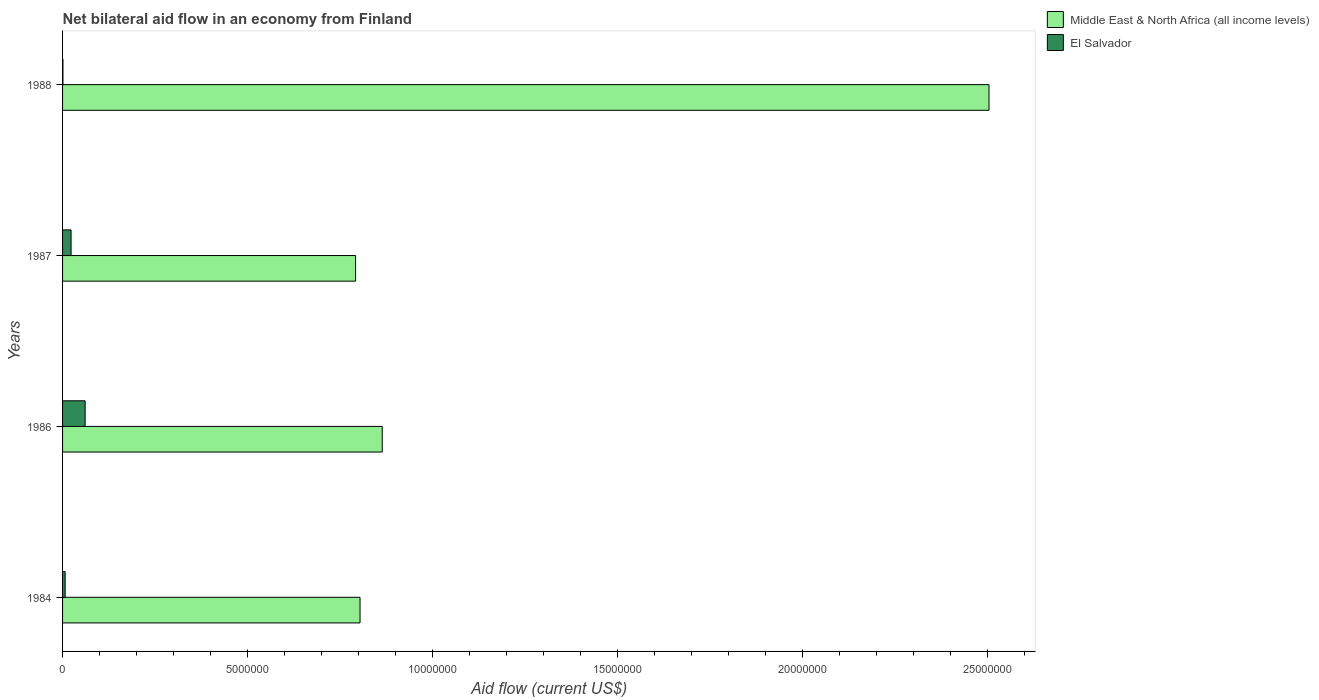How many groups of bars are there?
Your response must be concise. 4. Are the number of bars per tick equal to the number of legend labels?
Make the answer very short. Yes. How many bars are there on the 3rd tick from the top?
Provide a succinct answer. 2. How many bars are there on the 2nd tick from the bottom?
Your answer should be compact. 2. What is the label of the 2nd group of bars from the top?
Give a very brief answer. 1987. In how many cases, is the number of bars for a given year not equal to the number of legend labels?
Make the answer very short. 0. What is the net bilateral aid flow in Middle East & North Africa (all income levels) in 1987?
Make the answer very short. 7.92e+06. Across all years, what is the minimum net bilateral aid flow in Middle East & North Africa (all income levels)?
Your answer should be compact. 7.92e+06. In which year was the net bilateral aid flow in Middle East & North Africa (all income levels) minimum?
Provide a short and direct response. 1987. What is the total net bilateral aid flow in Middle East & North Africa (all income levels) in the graph?
Your answer should be compact. 4.96e+07. What is the difference between the net bilateral aid flow in Middle East & North Africa (all income levels) in 1984 and that in 1987?
Ensure brevity in your answer.  1.20e+05. What is the difference between the net bilateral aid flow in El Salvador in 1988 and the net bilateral aid flow in Middle East & North Africa (all income levels) in 1986?
Make the answer very short. -8.63e+06. What is the average net bilateral aid flow in El Salvador per year?
Keep it short and to the point. 2.30e+05. In the year 1988, what is the difference between the net bilateral aid flow in El Salvador and net bilateral aid flow in Middle East & North Africa (all income levels)?
Your answer should be very brief. -2.50e+07. In how many years, is the net bilateral aid flow in El Salvador greater than 1000000 US$?
Your answer should be compact. 0. What is the ratio of the net bilateral aid flow in Middle East & North Africa (all income levels) in 1984 to that in 1986?
Offer a very short reply. 0.93. Is the net bilateral aid flow in Middle East & North Africa (all income levels) in 1984 less than that in 1988?
Your answer should be compact. Yes. Is the difference between the net bilateral aid flow in El Salvador in 1984 and 1988 greater than the difference between the net bilateral aid flow in Middle East & North Africa (all income levels) in 1984 and 1988?
Your answer should be compact. Yes. What is the difference between the highest and the second highest net bilateral aid flow in Middle East & North Africa (all income levels)?
Make the answer very short. 1.64e+07. What is the difference between the highest and the lowest net bilateral aid flow in Middle East & North Africa (all income levels)?
Make the answer very short. 1.71e+07. Is the sum of the net bilateral aid flow in Middle East & North Africa (all income levels) in 1984 and 1987 greater than the maximum net bilateral aid flow in El Salvador across all years?
Keep it short and to the point. Yes. What does the 2nd bar from the top in 1986 represents?
Your response must be concise. Middle East & North Africa (all income levels). What does the 2nd bar from the bottom in 1987 represents?
Your answer should be very brief. El Salvador. How many bars are there?
Offer a terse response. 8. Are all the bars in the graph horizontal?
Keep it short and to the point. Yes. How many years are there in the graph?
Your answer should be very brief. 4. Are the values on the major ticks of X-axis written in scientific E-notation?
Your answer should be compact. No. Does the graph contain any zero values?
Your response must be concise. No. How are the legend labels stacked?
Offer a terse response. Vertical. What is the title of the graph?
Your answer should be very brief. Net bilateral aid flow in an economy from Finland. Does "Djibouti" appear as one of the legend labels in the graph?
Ensure brevity in your answer.  No. What is the label or title of the X-axis?
Ensure brevity in your answer.  Aid flow (current US$). What is the label or title of the Y-axis?
Offer a terse response. Years. What is the Aid flow (current US$) in Middle East & North Africa (all income levels) in 1984?
Offer a very short reply. 8.04e+06. What is the Aid flow (current US$) in Middle East & North Africa (all income levels) in 1986?
Provide a succinct answer. 8.64e+06. What is the Aid flow (current US$) in Middle East & North Africa (all income levels) in 1987?
Offer a terse response. 7.92e+06. What is the Aid flow (current US$) of Middle East & North Africa (all income levels) in 1988?
Provide a short and direct response. 2.50e+07. What is the Aid flow (current US$) in El Salvador in 1988?
Give a very brief answer. 10000. Across all years, what is the maximum Aid flow (current US$) of Middle East & North Africa (all income levels)?
Ensure brevity in your answer.  2.50e+07. Across all years, what is the minimum Aid flow (current US$) in Middle East & North Africa (all income levels)?
Keep it short and to the point. 7.92e+06. What is the total Aid flow (current US$) in Middle East & North Africa (all income levels) in the graph?
Ensure brevity in your answer.  4.96e+07. What is the total Aid flow (current US$) in El Salvador in the graph?
Provide a short and direct response. 9.20e+05. What is the difference between the Aid flow (current US$) in Middle East & North Africa (all income levels) in 1984 and that in 1986?
Offer a very short reply. -6.00e+05. What is the difference between the Aid flow (current US$) in El Salvador in 1984 and that in 1986?
Your answer should be compact. -5.40e+05. What is the difference between the Aid flow (current US$) in Middle East & North Africa (all income levels) in 1984 and that in 1987?
Keep it short and to the point. 1.20e+05. What is the difference between the Aid flow (current US$) of El Salvador in 1984 and that in 1987?
Your answer should be very brief. -1.60e+05. What is the difference between the Aid flow (current US$) in Middle East & North Africa (all income levels) in 1984 and that in 1988?
Give a very brief answer. -1.70e+07. What is the difference between the Aid flow (current US$) in Middle East & North Africa (all income levels) in 1986 and that in 1987?
Keep it short and to the point. 7.20e+05. What is the difference between the Aid flow (current US$) of Middle East & North Africa (all income levels) in 1986 and that in 1988?
Ensure brevity in your answer.  -1.64e+07. What is the difference between the Aid flow (current US$) in Middle East & North Africa (all income levels) in 1987 and that in 1988?
Your answer should be compact. -1.71e+07. What is the difference between the Aid flow (current US$) in Middle East & North Africa (all income levels) in 1984 and the Aid flow (current US$) in El Salvador in 1986?
Ensure brevity in your answer.  7.43e+06. What is the difference between the Aid flow (current US$) of Middle East & North Africa (all income levels) in 1984 and the Aid flow (current US$) of El Salvador in 1987?
Your answer should be very brief. 7.81e+06. What is the difference between the Aid flow (current US$) of Middle East & North Africa (all income levels) in 1984 and the Aid flow (current US$) of El Salvador in 1988?
Provide a short and direct response. 8.03e+06. What is the difference between the Aid flow (current US$) of Middle East & North Africa (all income levels) in 1986 and the Aid flow (current US$) of El Salvador in 1987?
Give a very brief answer. 8.41e+06. What is the difference between the Aid flow (current US$) in Middle East & North Africa (all income levels) in 1986 and the Aid flow (current US$) in El Salvador in 1988?
Your response must be concise. 8.63e+06. What is the difference between the Aid flow (current US$) of Middle East & North Africa (all income levels) in 1987 and the Aid flow (current US$) of El Salvador in 1988?
Make the answer very short. 7.91e+06. What is the average Aid flow (current US$) of Middle East & North Africa (all income levels) per year?
Give a very brief answer. 1.24e+07. What is the average Aid flow (current US$) in El Salvador per year?
Make the answer very short. 2.30e+05. In the year 1984, what is the difference between the Aid flow (current US$) of Middle East & North Africa (all income levels) and Aid flow (current US$) of El Salvador?
Your answer should be very brief. 7.97e+06. In the year 1986, what is the difference between the Aid flow (current US$) in Middle East & North Africa (all income levels) and Aid flow (current US$) in El Salvador?
Your answer should be compact. 8.03e+06. In the year 1987, what is the difference between the Aid flow (current US$) of Middle East & North Africa (all income levels) and Aid flow (current US$) of El Salvador?
Offer a very short reply. 7.69e+06. In the year 1988, what is the difference between the Aid flow (current US$) in Middle East & North Africa (all income levels) and Aid flow (current US$) in El Salvador?
Ensure brevity in your answer.  2.50e+07. What is the ratio of the Aid flow (current US$) in Middle East & North Africa (all income levels) in 1984 to that in 1986?
Ensure brevity in your answer.  0.93. What is the ratio of the Aid flow (current US$) in El Salvador in 1984 to that in 1986?
Your response must be concise. 0.11. What is the ratio of the Aid flow (current US$) of Middle East & North Africa (all income levels) in 1984 to that in 1987?
Provide a short and direct response. 1.02. What is the ratio of the Aid flow (current US$) in El Salvador in 1984 to that in 1987?
Your response must be concise. 0.3. What is the ratio of the Aid flow (current US$) in Middle East & North Africa (all income levels) in 1984 to that in 1988?
Give a very brief answer. 0.32. What is the ratio of the Aid flow (current US$) of El Salvador in 1984 to that in 1988?
Keep it short and to the point. 7. What is the ratio of the Aid flow (current US$) of Middle East & North Africa (all income levels) in 1986 to that in 1987?
Your response must be concise. 1.09. What is the ratio of the Aid flow (current US$) in El Salvador in 1986 to that in 1987?
Provide a short and direct response. 2.65. What is the ratio of the Aid flow (current US$) in Middle East & North Africa (all income levels) in 1986 to that in 1988?
Give a very brief answer. 0.34. What is the ratio of the Aid flow (current US$) of Middle East & North Africa (all income levels) in 1987 to that in 1988?
Provide a short and direct response. 0.32. What is the difference between the highest and the second highest Aid flow (current US$) of Middle East & North Africa (all income levels)?
Your response must be concise. 1.64e+07. What is the difference between the highest and the lowest Aid flow (current US$) of Middle East & North Africa (all income levels)?
Make the answer very short. 1.71e+07. 